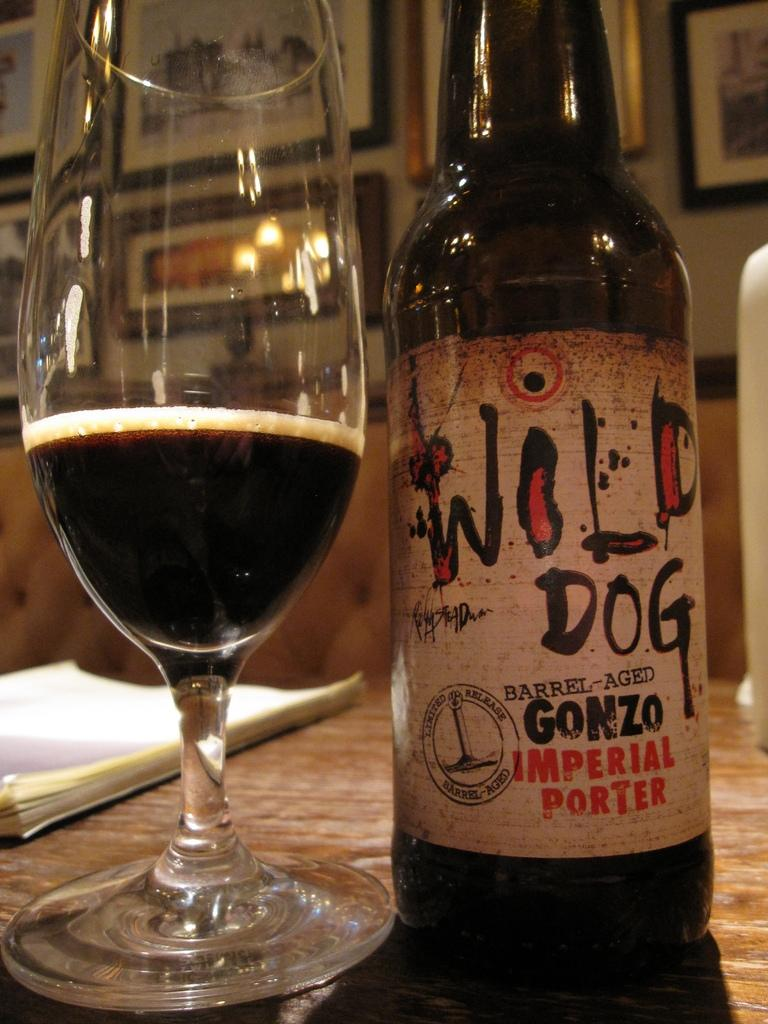What objects are on the table in the image? There is a bottle, a glass, and a book on the table in the image. What can be seen behind the objects on the table? There are photo frames visible behind the objects on the table. What type of rhythm can be heard coming from the houses in the image? There are no houses present in the image, so it's not possible to determine what, if any, rhythm might be heard. 